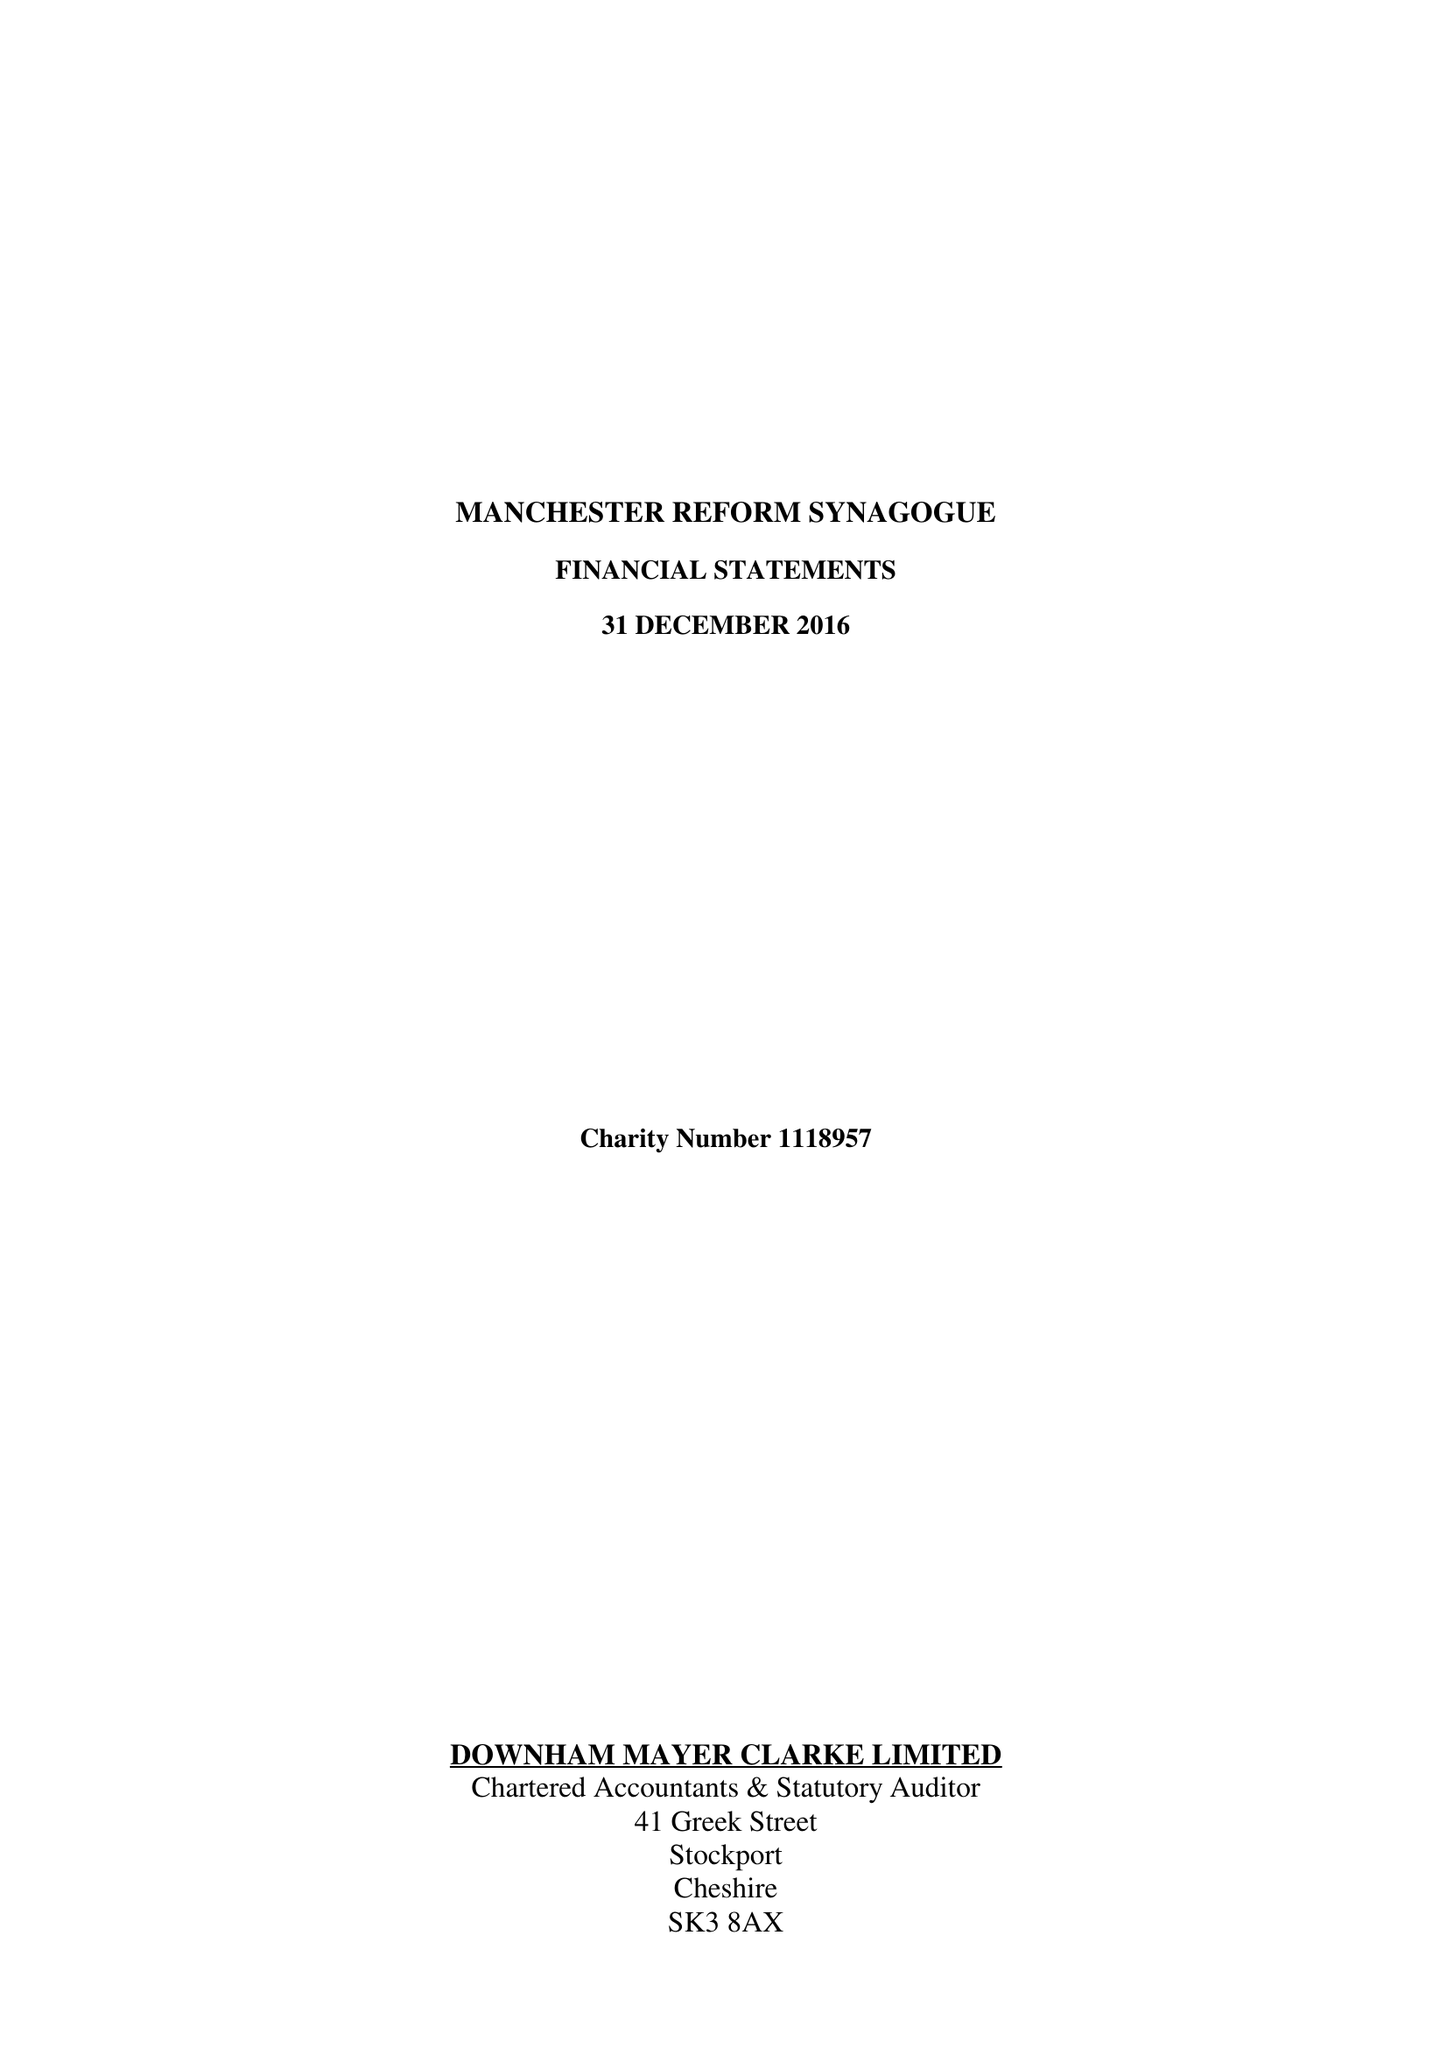What is the value for the income_annually_in_british_pounds?
Answer the question using a single word or phrase. 324000.00 